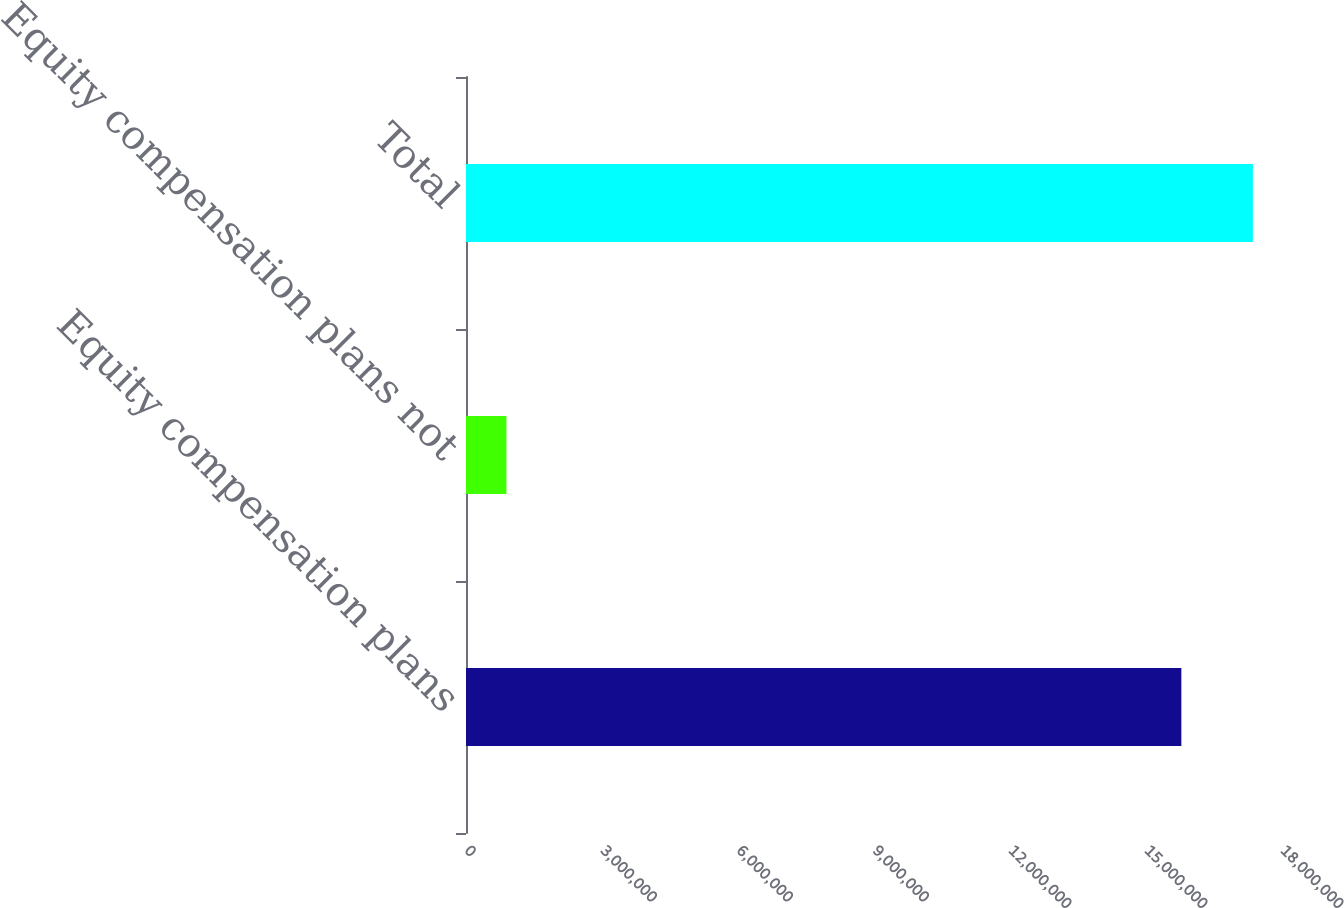Convert chart. <chart><loc_0><loc_0><loc_500><loc_500><bar_chart><fcel>Equity compensation plans<fcel>Equity compensation plans not<fcel>Total<nl><fcel>1.57797e+07<fcel>891900<fcel>1.73577e+07<nl></chart> 